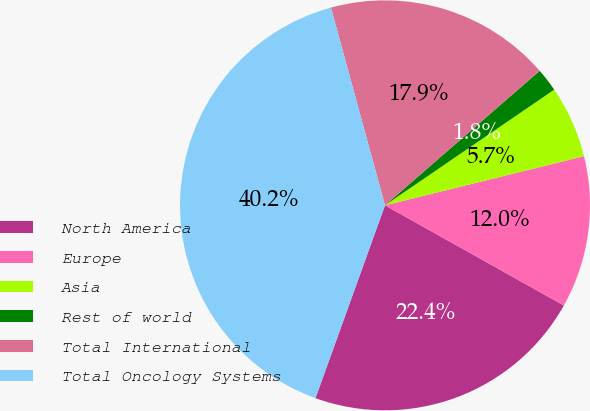<chart> <loc_0><loc_0><loc_500><loc_500><pie_chart><fcel>North America<fcel>Europe<fcel>Asia<fcel>Rest of world<fcel>Total International<fcel>Total Oncology Systems<nl><fcel>22.39%<fcel>11.98%<fcel>5.69%<fcel>1.85%<fcel>17.86%<fcel>40.25%<nl></chart> 